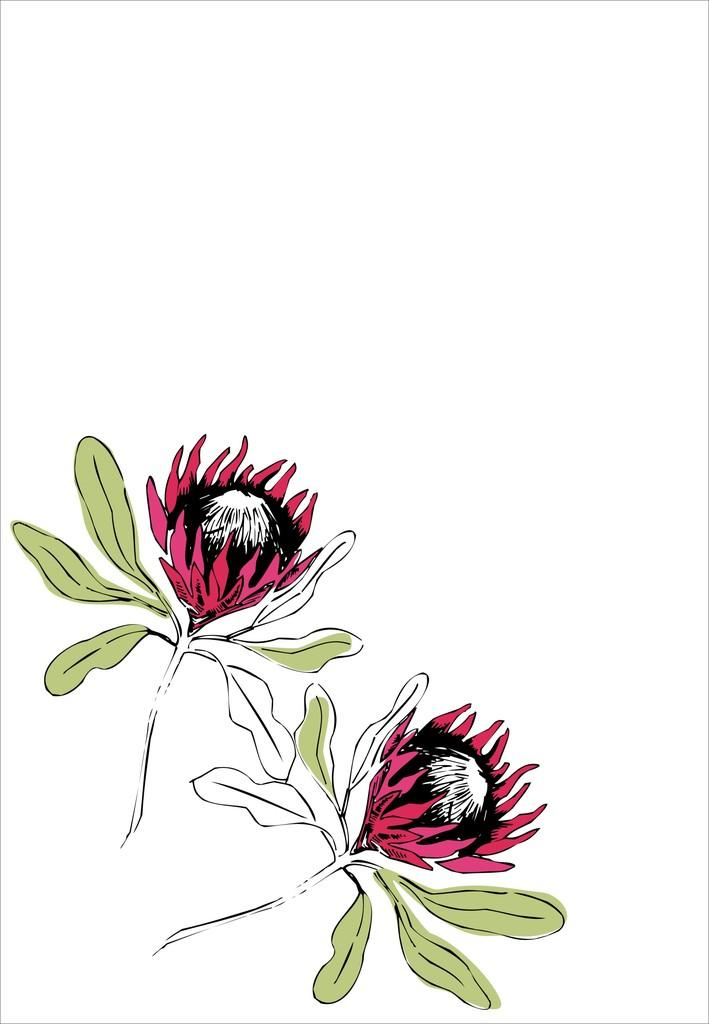What is the main subject of the image? There is a painting in the image. What is depicted in the painting? The painting depicts two flowers. What type of coat is hanging in the hall in the image? There is no coat or hall present in the image; it only features a painting of two flowers. 